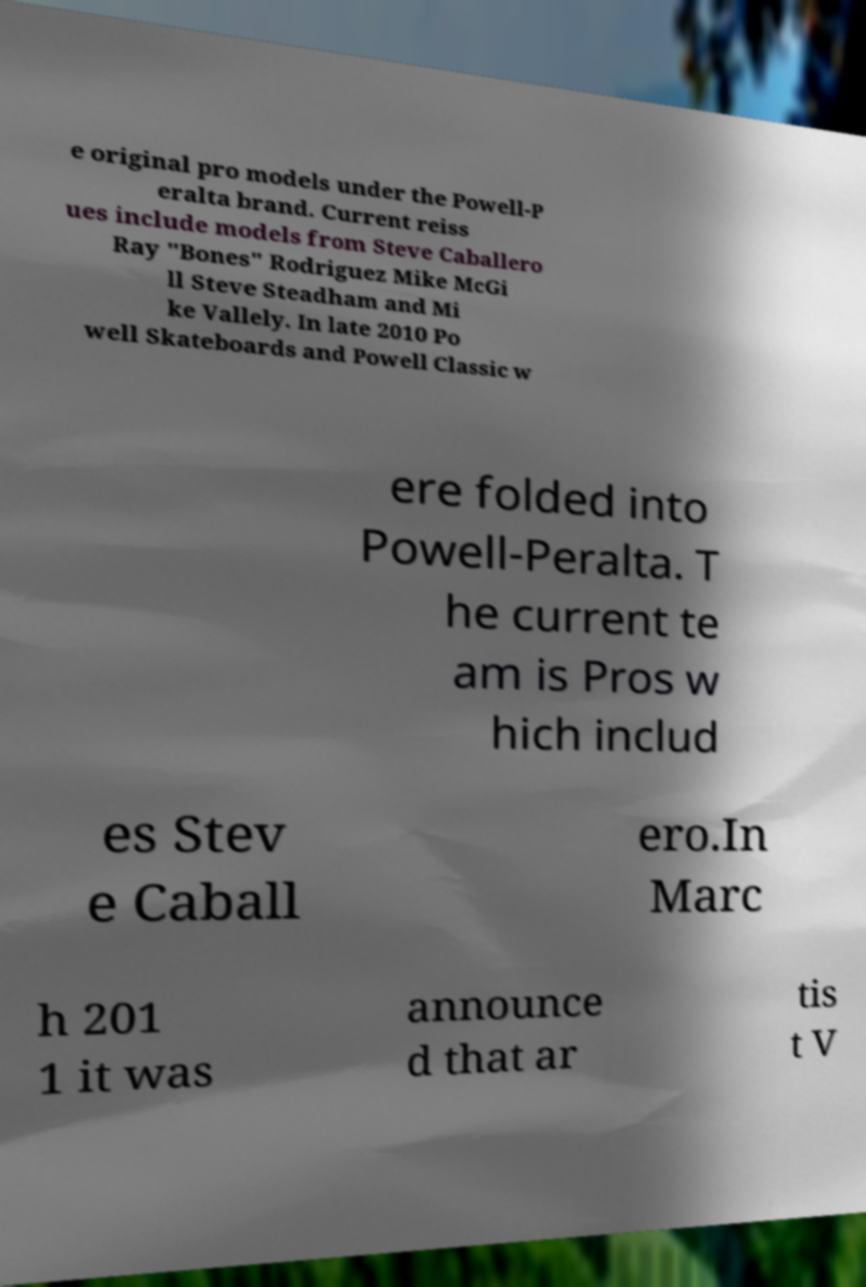Can you read and provide the text displayed in the image?This photo seems to have some interesting text. Can you extract and type it out for me? e original pro models under the Powell-P eralta brand. Current reiss ues include models from Steve Caballero Ray "Bones" Rodriguez Mike McGi ll Steve Steadham and Mi ke Vallely. In late 2010 Po well Skateboards and Powell Classic w ere folded into Powell-Peralta. T he current te am is Pros w hich includ es Stev e Caball ero.In Marc h 201 1 it was announce d that ar tis t V 